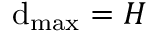<formula> <loc_0><loc_0><loc_500><loc_500>d _ { \max } = H</formula> 